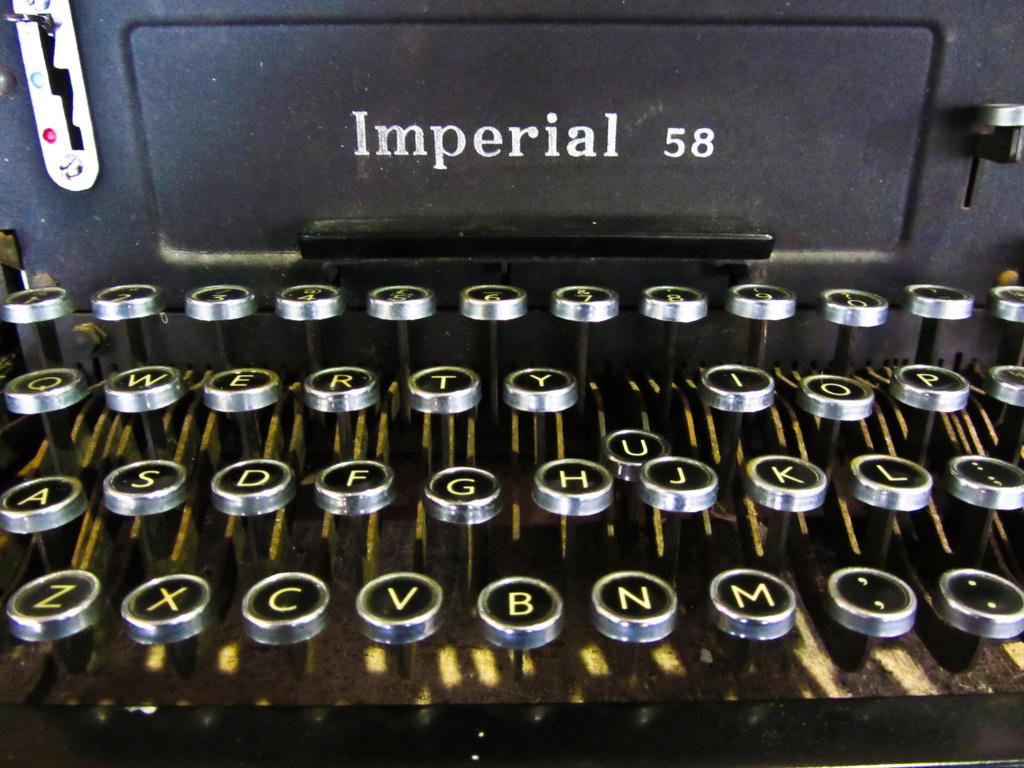Which key is stuck?
Make the answer very short. U. What is the name of this typewriter?
Ensure brevity in your answer.  Imperial 58. 